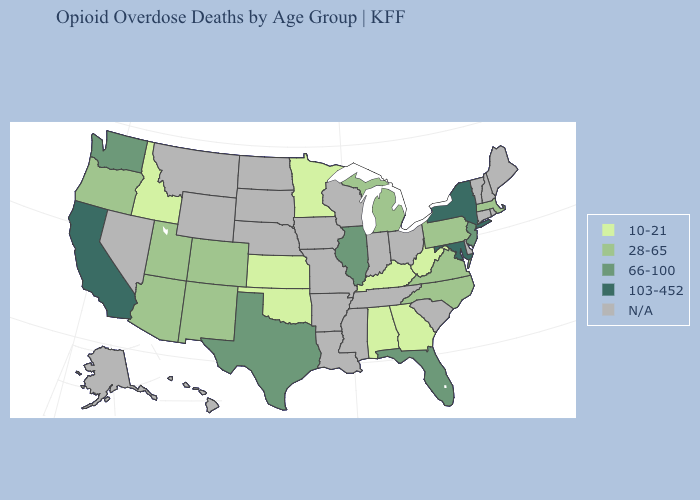Among the states that border New York , which have the lowest value?
Keep it brief. Massachusetts, Pennsylvania. Does the first symbol in the legend represent the smallest category?
Be succinct. Yes. What is the lowest value in the USA?
Give a very brief answer. 10-21. What is the value of Wyoming?
Quick response, please. N/A. Among the states that border Colorado , which have the highest value?
Give a very brief answer. Arizona, New Mexico, Utah. Name the states that have a value in the range N/A?
Short answer required. Alaska, Arkansas, Connecticut, Delaware, Hawaii, Indiana, Iowa, Louisiana, Maine, Mississippi, Missouri, Montana, Nebraska, Nevada, New Hampshire, North Dakota, Ohio, Rhode Island, South Carolina, South Dakota, Tennessee, Vermont, Wisconsin, Wyoming. Is the legend a continuous bar?
Short answer required. No. Name the states that have a value in the range 66-100?
Answer briefly. Florida, Illinois, New Jersey, Texas, Washington. What is the value of Illinois?
Keep it brief. 66-100. What is the lowest value in the USA?
Keep it brief. 10-21. What is the value of Colorado?
Concise answer only. 28-65. How many symbols are there in the legend?
Concise answer only. 5. Which states have the lowest value in the MidWest?
Concise answer only. Kansas, Minnesota. What is the value of New Jersey?
Give a very brief answer. 66-100. 